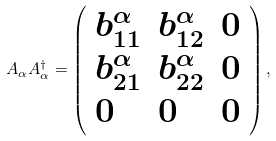Convert formula to latex. <formula><loc_0><loc_0><loc_500><loc_500>A _ { \alpha } A _ { \alpha } ^ { \dagger } = \left ( \begin{array} { l l l } b _ { 1 1 } ^ { \alpha } & b _ { 1 2 } ^ { \alpha } & 0 \\ b _ { 2 1 } ^ { \alpha } & b _ { 2 2 } ^ { \alpha } & 0 \\ 0 & 0 & 0 \end{array} \right ) ,</formula> 